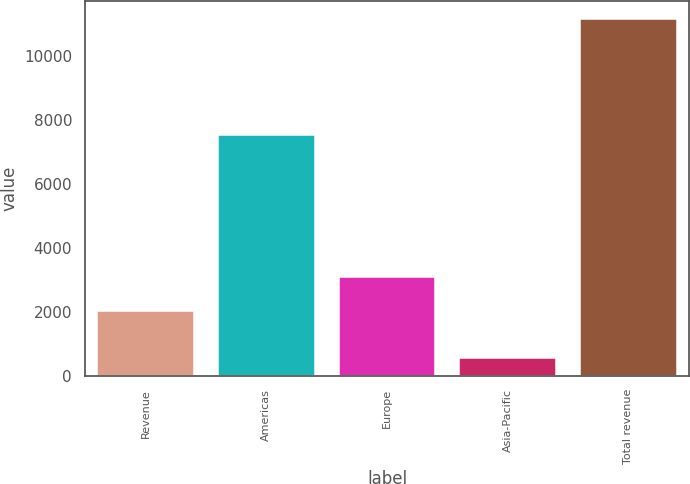Convert chart. <chart><loc_0><loc_0><loc_500><loc_500><bar_chart><fcel>Revenue<fcel>Americas<fcel>Europe<fcel>Asia-Pacific<fcel>Total revenue<nl><fcel>2016<fcel>7530<fcel>3083<fcel>542<fcel>11155<nl></chart> 